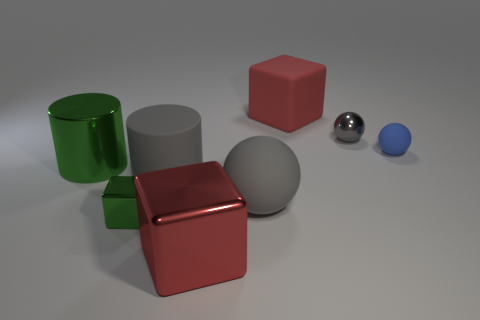The gray ball on the left side of the cube behind the small gray metallic sphere is made of what material?
Offer a terse response. Rubber. Are the large gray cylinder and the sphere to the right of the tiny gray metal object made of the same material?
Keep it short and to the point. Yes. The ball that is behind the big green object and in front of the gray metal thing is made of what material?
Offer a terse response. Rubber. The small thing in front of the matte sphere left of the big red matte object is what color?
Offer a very short reply. Green. There is a block that is to the left of the gray rubber cylinder; what is it made of?
Your answer should be very brief. Metal. Are there fewer large green metal cylinders than small gray rubber cubes?
Make the answer very short. No. Do the tiny gray thing and the blue matte thing behind the small green shiny object have the same shape?
Provide a succinct answer. Yes. What is the shape of the metal thing that is both to the left of the large rubber cube and to the right of the small metallic cube?
Make the answer very short. Cube. Are there the same number of metallic blocks that are right of the tiny blue object and red blocks to the left of the big gray sphere?
Keep it short and to the point. No. There is a big object that is behind the tiny matte ball; is it the same shape as the large red shiny thing?
Make the answer very short. Yes. 